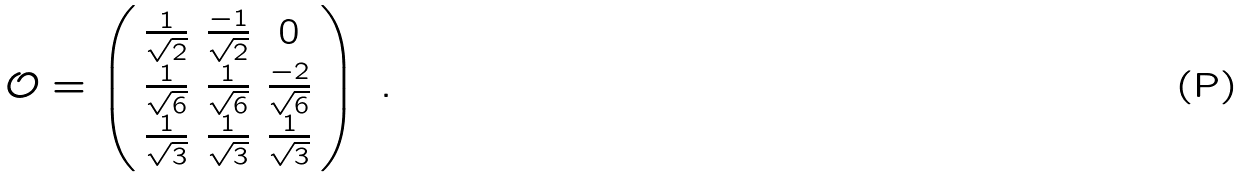<formula> <loc_0><loc_0><loc_500><loc_500>\mathcal { O } = \left ( \begin{array} { c c c } \frac { 1 } { \sqrt { 2 } } & \frac { - 1 } { \sqrt { 2 } } & 0 \\ \frac { 1 } { \sqrt { 6 } } & \frac { 1 } { \sqrt { 6 } } & \frac { - 2 } { \sqrt { 6 } } \\ \frac { 1 } { \sqrt { 3 } } & \frac { 1 } { \sqrt { 3 } } & \frac { 1 } { \sqrt { 3 } } \end{array} \right ) \ .</formula> 